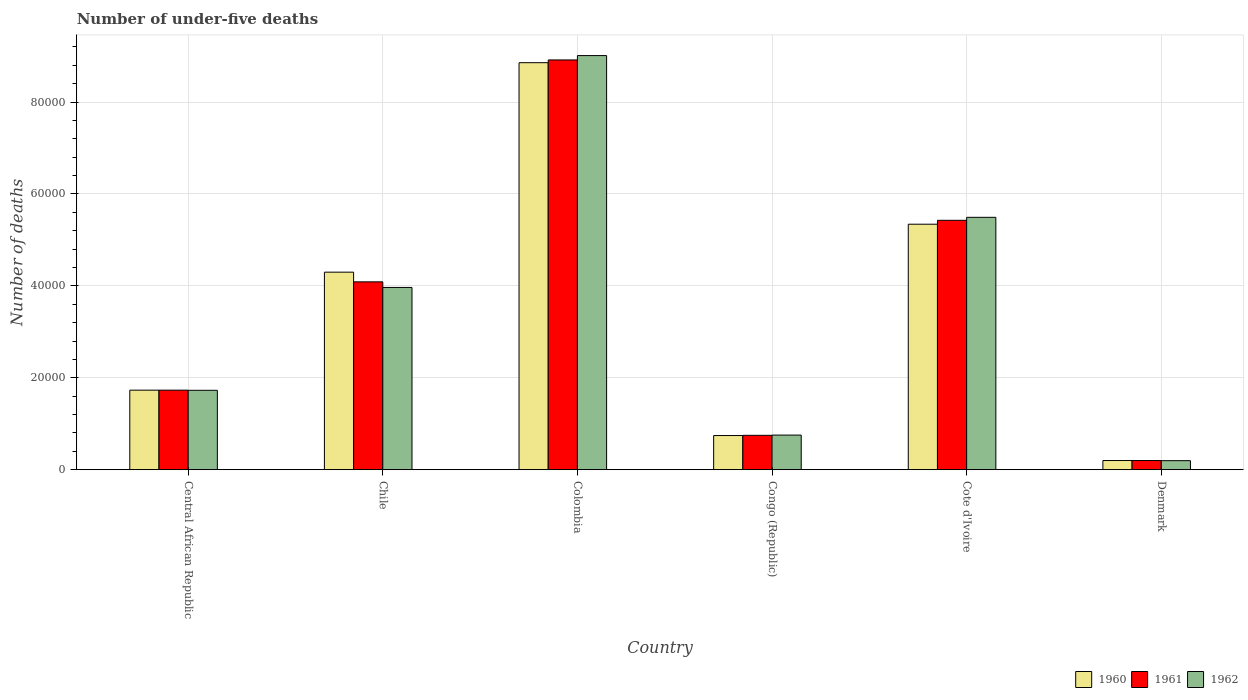How many different coloured bars are there?
Provide a succinct answer. 3. Are the number of bars per tick equal to the number of legend labels?
Your answer should be compact. Yes. How many bars are there on the 3rd tick from the left?
Your answer should be very brief. 3. How many bars are there on the 2nd tick from the right?
Offer a terse response. 3. What is the label of the 1st group of bars from the left?
Your answer should be very brief. Central African Republic. In how many cases, is the number of bars for a given country not equal to the number of legend labels?
Offer a terse response. 0. What is the number of under-five deaths in 1960 in Congo (Republic)?
Provide a succinct answer. 7431. Across all countries, what is the maximum number of under-five deaths in 1960?
Your response must be concise. 8.86e+04. Across all countries, what is the minimum number of under-five deaths in 1960?
Provide a short and direct response. 1995. In which country was the number of under-five deaths in 1962 minimum?
Give a very brief answer. Denmark. What is the total number of under-five deaths in 1960 in the graph?
Offer a very short reply. 2.12e+05. What is the difference between the number of under-five deaths in 1961 in Colombia and that in Congo (Republic)?
Your response must be concise. 8.17e+04. What is the difference between the number of under-five deaths in 1962 in Congo (Republic) and the number of under-five deaths in 1960 in Central African Republic?
Keep it short and to the point. -9775. What is the average number of under-five deaths in 1961 per country?
Your answer should be compact. 3.52e+04. What is the difference between the number of under-five deaths of/in 1961 and number of under-five deaths of/in 1962 in Cote d'Ivoire?
Keep it short and to the point. -648. What is the ratio of the number of under-five deaths in 1962 in Chile to that in Colombia?
Give a very brief answer. 0.44. What is the difference between the highest and the second highest number of under-five deaths in 1960?
Your response must be concise. -3.51e+04. What is the difference between the highest and the lowest number of under-five deaths in 1960?
Offer a very short reply. 8.66e+04. What does the 3rd bar from the left in Central African Republic represents?
Keep it short and to the point. 1962. Are all the bars in the graph horizontal?
Your answer should be very brief. No. How many countries are there in the graph?
Provide a succinct answer. 6. What is the difference between two consecutive major ticks on the Y-axis?
Make the answer very short. 2.00e+04. Does the graph contain any zero values?
Make the answer very short. No. Does the graph contain grids?
Offer a very short reply. Yes. What is the title of the graph?
Your response must be concise. Number of under-five deaths. Does "1975" appear as one of the legend labels in the graph?
Offer a very short reply. No. What is the label or title of the Y-axis?
Keep it short and to the point. Number of deaths. What is the Number of deaths in 1960 in Central African Republic?
Offer a terse response. 1.73e+04. What is the Number of deaths of 1961 in Central African Republic?
Provide a succinct answer. 1.73e+04. What is the Number of deaths of 1962 in Central African Republic?
Make the answer very short. 1.73e+04. What is the Number of deaths of 1960 in Chile?
Provide a succinct answer. 4.30e+04. What is the Number of deaths of 1961 in Chile?
Your answer should be compact. 4.09e+04. What is the Number of deaths in 1962 in Chile?
Provide a short and direct response. 3.97e+04. What is the Number of deaths in 1960 in Colombia?
Provide a short and direct response. 8.86e+04. What is the Number of deaths of 1961 in Colombia?
Make the answer very short. 8.92e+04. What is the Number of deaths of 1962 in Colombia?
Your response must be concise. 9.01e+04. What is the Number of deaths of 1960 in Congo (Republic)?
Keep it short and to the point. 7431. What is the Number of deaths in 1961 in Congo (Republic)?
Offer a terse response. 7480. What is the Number of deaths of 1962 in Congo (Republic)?
Make the answer very short. 7530. What is the Number of deaths in 1960 in Cote d'Ivoire?
Your response must be concise. 5.34e+04. What is the Number of deaths of 1961 in Cote d'Ivoire?
Your response must be concise. 5.43e+04. What is the Number of deaths in 1962 in Cote d'Ivoire?
Provide a short and direct response. 5.49e+04. What is the Number of deaths of 1960 in Denmark?
Ensure brevity in your answer.  1995. What is the Number of deaths in 1961 in Denmark?
Your response must be concise. 1997. What is the Number of deaths of 1962 in Denmark?
Ensure brevity in your answer.  1964. Across all countries, what is the maximum Number of deaths in 1960?
Offer a very short reply. 8.86e+04. Across all countries, what is the maximum Number of deaths of 1961?
Offer a very short reply. 8.92e+04. Across all countries, what is the maximum Number of deaths of 1962?
Keep it short and to the point. 9.01e+04. Across all countries, what is the minimum Number of deaths of 1960?
Give a very brief answer. 1995. Across all countries, what is the minimum Number of deaths of 1961?
Offer a terse response. 1997. Across all countries, what is the minimum Number of deaths of 1962?
Your response must be concise. 1964. What is the total Number of deaths in 1960 in the graph?
Offer a very short reply. 2.12e+05. What is the total Number of deaths of 1961 in the graph?
Provide a succinct answer. 2.11e+05. What is the total Number of deaths in 1962 in the graph?
Give a very brief answer. 2.11e+05. What is the difference between the Number of deaths in 1960 in Central African Republic and that in Chile?
Provide a succinct answer. -2.57e+04. What is the difference between the Number of deaths in 1961 in Central African Republic and that in Chile?
Give a very brief answer. -2.36e+04. What is the difference between the Number of deaths in 1962 in Central African Republic and that in Chile?
Give a very brief answer. -2.24e+04. What is the difference between the Number of deaths in 1960 in Central African Republic and that in Colombia?
Make the answer very short. -7.13e+04. What is the difference between the Number of deaths of 1961 in Central African Republic and that in Colombia?
Give a very brief answer. -7.18e+04. What is the difference between the Number of deaths in 1962 in Central African Republic and that in Colombia?
Your answer should be very brief. -7.28e+04. What is the difference between the Number of deaths in 1960 in Central African Republic and that in Congo (Republic)?
Ensure brevity in your answer.  9874. What is the difference between the Number of deaths in 1961 in Central African Republic and that in Congo (Republic)?
Give a very brief answer. 9826. What is the difference between the Number of deaths of 1962 in Central African Republic and that in Congo (Republic)?
Offer a terse response. 9743. What is the difference between the Number of deaths in 1960 in Central African Republic and that in Cote d'Ivoire?
Your answer should be very brief. -3.61e+04. What is the difference between the Number of deaths in 1961 in Central African Republic and that in Cote d'Ivoire?
Give a very brief answer. -3.70e+04. What is the difference between the Number of deaths in 1962 in Central African Republic and that in Cote d'Ivoire?
Your answer should be compact. -3.76e+04. What is the difference between the Number of deaths of 1960 in Central African Republic and that in Denmark?
Provide a succinct answer. 1.53e+04. What is the difference between the Number of deaths in 1961 in Central African Republic and that in Denmark?
Offer a very short reply. 1.53e+04. What is the difference between the Number of deaths of 1962 in Central African Republic and that in Denmark?
Provide a succinct answer. 1.53e+04. What is the difference between the Number of deaths of 1960 in Chile and that in Colombia?
Provide a short and direct response. -4.56e+04. What is the difference between the Number of deaths of 1961 in Chile and that in Colombia?
Keep it short and to the point. -4.83e+04. What is the difference between the Number of deaths in 1962 in Chile and that in Colombia?
Make the answer very short. -5.04e+04. What is the difference between the Number of deaths of 1960 in Chile and that in Congo (Republic)?
Provide a succinct answer. 3.55e+04. What is the difference between the Number of deaths in 1961 in Chile and that in Congo (Republic)?
Give a very brief answer. 3.34e+04. What is the difference between the Number of deaths of 1962 in Chile and that in Congo (Republic)?
Offer a terse response. 3.21e+04. What is the difference between the Number of deaths of 1960 in Chile and that in Cote d'Ivoire?
Provide a succinct answer. -1.04e+04. What is the difference between the Number of deaths of 1961 in Chile and that in Cote d'Ivoire?
Provide a succinct answer. -1.34e+04. What is the difference between the Number of deaths in 1962 in Chile and that in Cote d'Ivoire?
Your answer should be compact. -1.53e+04. What is the difference between the Number of deaths of 1960 in Chile and that in Denmark?
Offer a terse response. 4.10e+04. What is the difference between the Number of deaths of 1961 in Chile and that in Denmark?
Your response must be concise. 3.89e+04. What is the difference between the Number of deaths of 1962 in Chile and that in Denmark?
Ensure brevity in your answer.  3.77e+04. What is the difference between the Number of deaths of 1960 in Colombia and that in Congo (Republic)?
Keep it short and to the point. 8.11e+04. What is the difference between the Number of deaths of 1961 in Colombia and that in Congo (Republic)?
Your answer should be very brief. 8.17e+04. What is the difference between the Number of deaths of 1962 in Colombia and that in Congo (Republic)?
Your answer should be very brief. 8.26e+04. What is the difference between the Number of deaths in 1960 in Colombia and that in Cote d'Ivoire?
Provide a short and direct response. 3.51e+04. What is the difference between the Number of deaths of 1961 in Colombia and that in Cote d'Ivoire?
Ensure brevity in your answer.  3.49e+04. What is the difference between the Number of deaths of 1962 in Colombia and that in Cote d'Ivoire?
Ensure brevity in your answer.  3.52e+04. What is the difference between the Number of deaths of 1960 in Colombia and that in Denmark?
Offer a terse response. 8.66e+04. What is the difference between the Number of deaths in 1961 in Colombia and that in Denmark?
Your answer should be very brief. 8.72e+04. What is the difference between the Number of deaths of 1962 in Colombia and that in Denmark?
Give a very brief answer. 8.81e+04. What is the difference between the Number of deaths in 1960 in Congo (Republic) and that in Cote d'Ivoire?
Provide a short and direct response. -4.60e+04. What is the difference between the Number of deaths in 1961 in Congo (Republic) and that in Cote d'Ivoire?
Ensure brevity in your answer.  -4.68e+04. What is the difference between the Number of deaths in 1962 in Congo (Republic) and that in Cote d'Ivoire?
Make the answer very short. -4.74e+04. What is the difference between the Number of deaths in 1960 in Congo (Republic) and that in Denmark?
Provide a succinct answer. 5436. What is the difference between the Number of deaths of 1961 in Congo (Republic) and that in Denmark?
Offer a terse response. 5483. What is the difference between the Number of deaths of 1962 in Congo (Republic) and that in Denmark?
Your response must be concise. 5566. What is the difference between the Number of deaths of 1960 in Cote d'Ivoire and that in Denmark?
Provide a succinct answer. 5.14e+04. What is the difference between the Number of deaths of 1961 in Cote d'Ivoire and that in Denmark?
Your answer should be very brief. 5.23e+04. What is the difference between the Number of deaths in 1962 in Cote d'Ivoire and that in Denmark?
Ensure brevity in your answer.  5.29e+04. What is the difference between the Number of deaths in 1960 in Central African Republic and the Number of deaths in 1961 in Chile?
Offer a very short reply. -2.36e+04. What is the difference between the Number of deaths in 1960 in Central African Republic and the Number of deaths in 1962 in Chile?
Provide a short and direct response. -2.24e+04. What is the difference between the Number of deaths in 1961 in Central African Republic and the Number of deaths in 1962 in Chile?
Your answer should be very brief. -2.23e+04. What is the difference between the Number of deaths of 1960 in Central African Republic and the Number of deaths of 1961 in Colombia?
Keep it short and to the point. -7.19e+04. What is the difference between the Number of deaths in 1960 in Central African Republic and the Number of deaths in 1962 in Colombia?
Your answer should be compact. -7.28e+04. What is the difference between the Number of deaths in 1961 in Central African Republic and the Number of deaths in 1962 in Colombia?
Offer a terse response. -7.28e+04. What is the difference between the Number of deaths of 1960 in Central African Republic and the Number of deaths of 1961 in Congo (Republic)?
Give a very brief answer. 9825. What is the difference between the Number of deaths of 1960 in Central African Republic and the Number of deaths of 1962 in Congo (Republic)?
Your answer should be very brief. 9775. What is the difference between the Number of deaths of 1961 in Central African Republic and the Number of deaths of 1962 in Congo (Republic)?
Your answer should be compact. 9776. What is the difference between the Number of deaths of 1960 in Central African Republic and the Number of deaths of 1961 in Cote d'Ivoire?
Your response must be concise. -3.70e+04. What is the difference between the Number of deaths in 1960 in Central African Republic and the Number of deaths in 1962 in Cote d'Ivoire?
Offer a very short reply. -3.76e+04. What is the difference between the Number of deaths of 1961 in Central African Republic and the Number of deaths of 1962 in Cote d'Ivoire?
Ensure brevity in your answer.  -3.76e+04. What is the difference between the Number of deaths in 1960 in Central African Republic and the Number of deaths in 1961 in Denmark?
Provide a short and direct response. 1.53e+04. What is the difference between the Number of deaths in 1960 in Central African Republic and the Number of deaths in 1962 in Denmark?
Provide a short and direct response. 1.53e+04. What is the difference between the Number of deaths in 1961 in Central African Republic and the Number of deaths in 1962 in Denmark?
Make the answer very short. 1.53e+04. What is the difference between the Number of deaths of 1960 in Chile and the Number of deaths of 1961 in Colombia?
Provide a succinct answer. -4.62e+04. What is the difference between the Number of deaths in 1960 in Chile and the Number of deaths in 1962 in Colombia?
Provide a succinct answer. -4.71e+04. What is the difference between the Number of deaths in 1961 in Chile and the Number of deaths in 1962 in Colombia?
Your answer should be very brief. -4.92e+04. What is the difference between the Number of deaths of 1960 in Chile and the Number of deaths of 1961 in Congo (Republic)?
Your response must be concise. 3.55e+04. What is the difference between the Number of deaths in 1960 in Chile and the Number of deaths in 1962 in Congo (Republic)?
Give a very brief answer. 3.54e+04. What is the difference between the Number of deaths of 1961 in Chile and the Number of deaths of 1962 in Congo (Republic)?
Your answer should be compact. 3.33e+04. What is the difference between the Number of deaths in 1960 in Chile and the Number of deaths in 1961 in Cote d'Ivoire?
Provide a succinct answer. -1.13e+04. What is the difference between the Number of deaths of 1960 in Chile and the Number of deaths of 1962 in Cote d'Ivoire?
Give a very brief answer. -1.19e+04. What is the difference between the Number of deaths of 1961 in Chile and the Number of deaths of 1962 in Cote d'Ivoire?
Your answer should be very brief. -1.40e+04. What is the difference between the Number of deaths in 1960 in Chile and the Number of deaths in 1961 in Denmark?
Offer a very short reply. 4.10e+04. What is the difference between the Number of deaths of 1960 in Chile and the Number of deaths of 1962 in Denmark?
Offer a very short reply. 4.10e+04. What is the difference between the Number of deaths of 1961 in Chile and the Number of deaths of 1962 in Denmark?
Make the answer very short. 3.89e+04. What is the difference between the Number of deaths in 1960 in Colombia and the Number of deaths in 1961 in Congo (Republic)?
Give a very brief answer. 8.11e+04. What is the difference between the Number of deaths in 1960 in Colombia and the Number of deaths in 1962 in Congo (Republic)?
Your answer should be very brief. 8.10e+04. What is the difference between the Number of deaths in 1961 in Colombia and the Number of deaths in 1962 in Congo (Republic)?
Make the answer very short. 8.16e+04. What is the difference between the Number of deaths of 1960 in Colombia and the Number of deaths of 1961 in Cote d'Ivoire?
Provide a succinct answer. 3.43e+04. What is the difference between the Number of deaths in 1960 in Colombia and the Number of deaths in 1962 in Cote d'Ivoire?
Provide a succinct answer. 3.36e+04. What is the difference between the Number of deaths in 1961 in Colombia and the Number of deaths in 1962 in Cote d'Ivoire?
Your answer should be very brief. 3.42e+04. What is the difference between the Number of deaths of 1960 in Colombia and the Number of deaths of 1961 in Denmark?
Offer a terse response. 8.66e+04. What is the difference between the Number of deaths in 1960 in Colombia and the Number of deaths in 1962 in Denmark?
Ensure brevity in your answer.  8.66e+04. What is the difference between the Number of deaths in 1961 in Colombia and the Number of deaths in 1962 in Denmark?
Your answer should be very brief. 8.72e+04. What is the difference between the Number of deaths of 1960 in Congo (Republic) and the Number of deaths of 1961 in Cote d'Ivoire?
Provide a short and direct response. -4.68e+04. What is the difference between the Number of deaths in 1960 in Congo (Republic) and the Number of deaths in 1962 in Cote d'Ivoire?
Make the answer very short. -4.75e+04. What is the difference between the Number of deaths of 1961 in Congo (Republic) and the Number of deaths of 1962 in Cote d'Ivoire?
Provide a short and direct response. -4.74e+04. What is the difference between the Number of deaths of 1960 in Congo (Republic) and the Number of deaths of 1961 in Denmark?
Your response must be concise. 5434. What is the difference between the Number of deaths in 1960 in Congo (Republic) and the Number of deaths in 1962 in Denmark?
Make the answer very short. 5467. What is the difference between the Number of deaths of 1961 in Congo (Republic) and the Number of deaths of 1962 in Denmark?
Give a very brief answer. 5516. What is the difference between the Number of deaths in 1960 in Cote d'Ivoire and the Number of deaths in 1961 in Denmark?
Your response must be concise. 5.14e+04. What is the difference between the Number of deaths of 1960 in Cote d'Ivoire and the Number of deaths of 1962 in Denmark?
Offer a very short reply. 5.14e+04. What is the difference between the Number of deaths in 1961 in Cote d'Ivoire and the Number of deaths in 1962 in Denmark?
Offer a terse response. 5.23e+04. What is the average Number of deaths in 1960 per country?
Ensure brevity in your answer.  3.53e+04. What is the average Number of deaths in 1961 per country?
Provide a succinct answer. 3.52e+04. What is the average Number of deaths of 1962 per country?
Ensure brevity in your answer.  3.52e+04. What is the difference between the Number of deaths in 1960 and Number of deaths in 1961 in Central African Republic?
Ensure brevity in your answer.  -1. What is the difference between the Number of deaths in 1960 and Number of deaths in 1962 in Central African Republic?
Make the answer very short. 32. What is the difference between the Number of deaths of 1960 and Number of deaths of 1961 in Chile?
Provide a succinct answer. 2108. What is the difference between the Number of deaths of 1960 and Number of deaths of 1962 in Chile?
Provide a succinct answer. 3325. What is the difference between the Number of deaths of 1961 and Number of deaths of 1962 in Chile?
Ensure brevity in your answer.  1217. What is the difference between the Number of deaths in 1960 and Number of deaths in 1961 in Colombia?
Keep it short and to the point. -600. What is the difference between the Number of deaths in 1960 and Number of deaths in 1962 in Colombia?
Make the answer very short. -1548. What is the difference between the Number of deaths in 1961 and Number of deaths in 1962 in Colombia?
Your answer should be compact. -948. What is the difference between the Number of deaths of 1960 and Number of deaths of 1961 in Congo (Republic)?
Offer a terse response. -49. What is the difference between the Number of deaths in 1960 and Number of deaths in 1962 in Congo (Republic)?
Your answer should be very brief. -99. What is the difference between the Number of deaths in 1960 and Number of deaths in 1961 in Cote d'Ivoire?
Offer a very short reply. -852. What is the difference between the Number of deaths in 1960 and Number of deaths in 1962 in Cote d'Ivoire?
Your response must be concise. -1500. What is the difference between the Number of deaths in 1961 and Number of deaths in 1962 in Cote d'Ivoire?
Your answer should be very brief. -648. What is the difference between the Number of deaths of 1960 and Number of deaths of 1961 in Denmark?
Keep it short and to the point. -2. What is the difference between the Number of deaths in 1961 and Number of deaths in 1962 in Denmark?
Make the answer very short. 33. What is the ratio of the Number of deaths of 1960 in Central African Republic to that in Chile?
Offer a terse response. 0.4. What is the ratio of the Number of deaths in 1961 in Central African Republic to that in Chile?
Give a very brief answer. 0.42. What is the ratio of the Number of deaths of 1962 in Central African Republic to that in Chile?
Your answer should be compact. 0.44. What is the ratio of the Number of deaths in 1960 in Central African Republic to that in Colombia?
Keep it short and to the point. 0.2. What is the ratio of the Number of deaths of 1961 in Central African Republic to that in Colombia?
Make the answer very short. 0.19. What is the ratio of the Number of deaths of 1962 in Central African Republic to that in Colombia?
Make the answer very short. 0.19. What is the ratio of the Number of deaths of 1960 in Central African Republic to that in Congo (Republic)?
Provide a succinct answer. 2.33. What is the ratio of the Number of deaths of 1961 in Central African Republic to that in Congo (Republic)?
Offer a very short reply. 2.31. What is the ratio of the Number of deaths of 1962 in Central African Republic to that in Congo (Republic)?
Provide a succinct answer. 2.29. What is the ratio of the Number of deaths of 1960 in Central African Republic to that in Cote d'Ivoire?
Your answer should be compact. 0.32. What is the ratio of the Number of deaths in 1961 in Central African Republic to that in Cote d'Ivoire?
Your answer should be compact. 0.32. What is the ratio of the Number of deaths of 1962 in Central African Republic to that in Cote d'Ivoire?
Offer a terse response. 0.31. What is the ratio of the Number of deaths in 1960 in Central African Republic to that in Denmark?
Make the answer very short. 8.67. What is the ratio of the Number of deaths of 1961 in Central African Republic to that in Denmark?
Your response must be concise. 8.67. What is the ratio of the Number of deaths in 1962 in Central African Republic to that in Denmark?
Offer a very short reply. 8.79. What is the ratio of the Number of deaths of 1960 in Chile to that in Colombia?
Give a very brief answer. 0.49. What is the ratio of the Number of deaths of 1961 in Chile to that in Colombia?
Give a very brief answer. 0.46. What is the ratio of the Number of deaths in 1962 in Chile to that in Colombia?
Your response must be concise. 0.44. What is the ratio of the Number of deaths in 1960 in Chile to that in Congo (Republic)?
Provide a short and direct response. 5.78. What is the ratio of the Number of deaths of 1961 in Chile to that in Congo (Republic)?
Offer a terse response. 5.46. What is the ratio of the Number of deaths of 1962 in Chile to that in Congo (Republic)?
Your answer should be compact. 5.27. What is the ratio of the Number of deaths of 1960 in Chile to that in Cote d'Ivoire?
Give a very brief answer. 0.8. What is the ratio of the Number of deaths of 1961 in Chile to that in Cote d'Ivoire?
Make the answer very short. 0.75. What is the ratio of the Number of deaths of 1962 in Chile to that in Cote d'Ivoire?
Your answer should be very brief. 0.72. What is the ratio of the Number of deaths in 1960 in Chile to that in Denmark?
Your answer should be very brief. 21.54. What is the ratio of the Number of deaths of 1961 in Chile to that in Denmark?
Offer a very short reply. 20.47. What is the ratio of the Number of deaths of 1962 in Chile to that in Denmark?
Make the answer very short. 20.19. What is the ratio of the Number of deaths of 1960 in Colombia to that in Congo (Republic)?
Provide a short and direct response. 11.92. What is the ratio of the Number of deaths of 1961 in Colombia to that in Congo (Republic)?
Offer a very short reply. 11.92. What is the ratio of the Number of deaths in 1962 in Colombia to that in Congo (Republic)?
Offer a very short reply. 11.97. What is the ratio of the Number of deaths in 1960 in Colombia to that in Cote d'Ivoire?
Make the answer very short. 1.66. What is the ratio of the Number of deaths of 1961 in Colombia to that in Cote d'Ivoire?
Make the answer very short. 1.64. What is the ratio of the Number of deaths of 1962 in Colombia to that in Cote d'Ivoire?
Offer a terse response. 1.64. What is the ratio of the Number of deaths in 1960 in Colombia to that in Denmark?
Your answer should be very brief. 44.39. What is the ratio of the Number of deaths of 1961 in Colombia to that in Denmark?
Ensure brevity in your answer.  44.65. What is the ratio of the Number of deaths of 1962 in Colombia to that in Denmark?
Provide a short and direct response. 45.88. What is the ratio of the Number of deaths of 1960 in Congo (Republic) to that in Cote d'Ivoire?
Provide a short and direct response. 0.14. What is the ratio of the Number of deaths of 1961 in Congo (Republic) to that in Cote d'Ivoire?
Provide a short and direct response. 0.14. What is the ratio of the Number of deaths of 1962 in Congo (Republic) to that in Cote d'Ivoire?
Offer a terse response. 0.14. What is the ratio of the Number of deaths of 1960 in Congo (Republic) to that in Denmark?
Your response must be concise. 3.72. What is the ratio of the Number of deaths in 1961 in Congo (Republic) to that in Denmark?
Ensure brevity in your answer.  3.75. What is the ratio of the Number of deaths of 1962 in Congo (Republic) to that in Denmark?
Offer a terse response. 3.83. What is the ratio of the Number of deaths of 1960 in Cote d'Ivoire to that in Denmark?
Offer a very short reply. 26.77. What is the ratio of the Number of deaths in 1961 in Cote d'Ivoire to that in Denmark?
Your response must be concise. 27.17. What is the ratio of the Number of deaths of 1962 in Cote d'Ivoire to that in Denmark?
Your answer should be very brief. 27.96. What is the difference between the highest and the second highest Number of deaths of 1960?
Your response must be concise. 3.51e+04. What is the difference between the highest and the second highest Number of deaths of 1961?
Give a very brief answer. 3.49e+04. What is the difference between the highest and the second highest Number of deaths of 1962?
Ensure brevity in your answer.  3.52e+04. What is the difference between the highest and the lowest Number of deaths in 1960?
Provide a short and direct response. 8.66e+04. What is the difference between the highest and the lowest Number of deaths in 1961?
Your answer should be very brief. 8.72e+04. What is the difference between the highest and the lowest Number of deaths in 1962?
Offer a very short reply. 8.81e+04. 